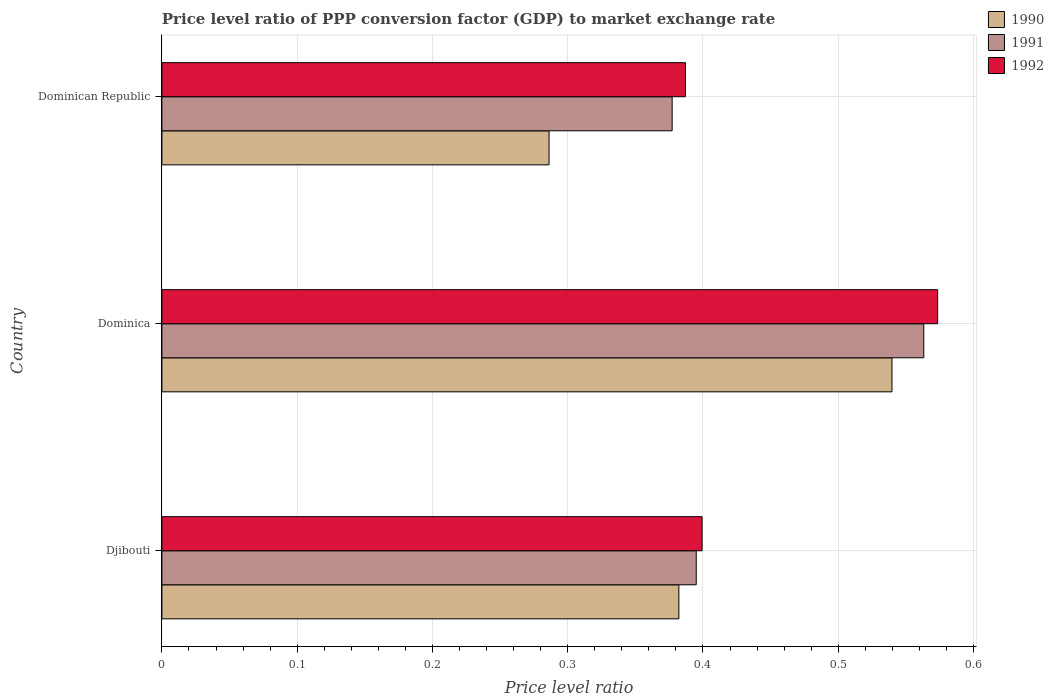How many different coloured bars are there?
Offer a terse response. 3. How many groups of bars are there?
Your answer should be compact. 3. Are the number of bars per tick equal to the number of legend labels?
Keep it short and to the point. Yes. How many bars are there on the 1st tick from the bottom?
Your response must be concise. 3. What is the label of the 3rd group of bars from the top?
Make the answer very short. Djibouti. What is the price level ratio in 1991 in Djibouti?
Offer a terse response. 0.4. Across all countries, what is the maximum price level ratio in 1990?
Make the answer very short. 0.54. Across all countries, what is the minimum price level ratio in 1991?
Make the answer very short. 0.38. In which country was the price level ratio in 1991 maximum?
Your answer should be very brief. Dominica. In which country was the price level ratio in 1990 minimum?
Provide a succinct answer. Dominican Republic. What is the total price level ratio in 1991 in the graph?
Make the answer very short. 1.34. What is the difference between the price level ratio in 1990 in Djibouti and that in Dominica?
Offer a terse response. -0.16. What is the difference between the price level ratio in 1992 in Dominica and the price level ratio in 1991 in Dominican Republic?
Ensure brevity in your answer.  0.2. What is the average price level ratio in 1991 per country?
Make the answer very short. 0.45. What is the difference between the price level ratio in 1990 and price level ratio in 1992 in Dominica?
Make the answer very short. -0.03. What is the ratio of the price level ratio in 1990 in Dominica to that in Dominican Republic?
Give a very brief answer. 1.89. Is the price level ratio in 1990 in Djibouti less than that in Dominica?
Offer a terse response. Yes. Is the difference between the price level ratio in 1990 in Djibouti and Dominican Republic greater than the difference between the price level ratio in 1992 in Djibouti and Dominican Republic?
Your answer should be compact. Yes. What is the difference between the highest and the second highest price level ratio in 1992?
Your answer should be compact. 0.17. What is the difference between the highest and the lowest price level ratio in 1990?
Offer a very short reply. 0.25. Is the sum of the price level ratio in 1990 in Djibouti and Dominica greater than the maximum price level ratio in 1991 across all countries?
Make the answer very short. Yes. What does the 1st bar from the top in Dominican Republic represents?
Ensure brevity in your answer.  1992. What does the 1st bar from the bottom in Dominica represents?
Keep it short and to the point. 1990. Does the graph contain any zero values?
Provide a succinct answer. No. Does the graph contain grids?
Keep it short and to the point. Yes. How many legend labels are there?
Your answer should be very brief. 3. How are the legend labels stacked?
Make the answer very short. Vertical. What is the title of the graph?
Keep it short and to the point. Price level ratio of PPP conversion factor (GDP) to market exchange rate. Does "1965" appear as one of the legend labels in the graph?
Offer a very short reply. No. What is the label or title of the X-axis?
Your answer should be very brief. Price level ratio. What is the label or title of the Y-axis?
Your answer should be compact. Country. What is the Price level ratio in 1990 in Djibouti?
Make the answer very short. 0.38. What is the Price level ratio in 1991 in Djibouti?
Make the answer very short. 0.4. What is the Price level ratio in 1992 in Djibouti?
Keep it short and to the point. 0.4. What is the Price level ratio in 1990 in Dominica?
Give a very brief answer. 0.54. What is the Price level ratio in 1991 in Dominica?
Make the answer very short. 0.56. What is the Price level ratio in 1992 in Dominica?
Provide a succinct answer. 0.57. What is the Price level ratio in 1990 in Dominican Republic?
Your response must be concise. 0.29. What is the Price level ratio in 1991 in Dominican Republic?
Ensure brevity in your answer.  0.38. What is the Price level ratio in 1992 in Dominican Republic?
Ensure brevity in your answer.  0.39. Across all countries, what is the maximum Price level ratio of 1990?
Your answer should be very brief. 0.54. Across all countries, what is the maximum Price level ratio of 1991?
Make the answer very short. 0.56. Across all countries, what is the maximum Price level ratio of 1992?
Offer a terse response. 0.57. Across all countries, what is the minimum Price level ratio of 1990?
Your answer should be compact. 0.29. Across all countries, what is the minimum Price level ratio in 1991?
Make the answer very short. 0.38. Across all countries, what is the minimum Price level ratio of 1992?
Keep it short and to the point. 0.39. What is the total Price level ratio of 1990 in the graph?
Your answer should be very brief. 1.21. What is the total Price level ratio in 1991 in the graph?
Your response must be concise. 1.34. What is the total Price level ratio of 1992 in the graph?
Your answer should be very brief. 1.36. What is the difference between the Price level ratio of 1990 in Djibouti and that in Dominica?
Your answer should be compact. -0.16. What is the difference between the Price level ratio of 1991 in Djibouti and that in Dominica?
Make the answer very short. -0.17. What is the difference between the Price level ratio of 1992 in Djibouti and that in Dominica?
Make the answer very short. -0.17. What is the difference between the Price level ratio in 1990 in Djibouti and that in Dominican Republic?
Your response must be concise. 0.1. What is the difference between the Price level ratio in 1991 in Djibouti and that in Dominican Republic?
Offer a terse response. 0.02. What is the difference between the Price level ratio in 1992 in Djibouti and that in Dominican Republic?
Give a very brief answer. 0.01. What is the difference between the Price level ratio of 1990 in Dominica and that in Dominican Republic?
Your response must be concise. 0.25. What is the difference between the Price level ratio of 1991 in Dominica and that in Dominican Republic?
Your response must be concise. 0.19. What is the difference between the Price level ratio in 1992 in Dominica and that in Dominican Republic?
Ensure brevity in your answer.  0.19. What is the difference between the Price level ratio of 1990 in Djibouti and the Price level ratio of 1991 in Dominica?
Offer a very short reply. -0.18. What is the difference between the Price level ratio of 1990 in Djibouti and the Price level ratio of 1992 in Dominica?
Make the answer very short. -0.19. What is the difference between the Price level ratio of 1991 in Djibouti and the Price level ratio of 1992 in Dominica?
Your answer should be very brief. -0.18. What is the difference between the Price level ratio of 1990 in Djibouti and the Price level ratio of 1991 in Dominican Republic?
Ensure brevity in your answer.  0.01. What is the difference between the Price level ratio in 1990 in Djibouti and the Price level ratio in 1992 in Dominican Republic?
Offer a terse response. -0. What is the difference between the Price level ratio of 1991 in Djibouti and the Price level ratio of 1992 in Dominican Republic?
Offer a very short reply. 0.01. What is the difference between the Price level ratio of 1990 in Dominica and the Price level ratio of 1991 in Dominican Republic?
Your response must be concise. 0.16. What is the difference between the Price level ratio in 1990 in Dominica and the Price level ratio in 1992 in Dominican Republic?
Provide a succinct answer. 0.15. What is the difference between the Price level ratio in 1991 in Dominica and the Price level ratio in 1992 in Dominican Republic?
Provide a short and direct response. 0.18. What is the average Price level ratio of 1990 per country?
Your response must be concise. 0.4. What is the average Price level ratio of 1991 per country?
Make the answer very short. 0.45. What is the average Price level ratio in 1992 per country?
Your answer should be very brief. 0.45. What is the difference between the Price level ratio of 1990 and Price level ratio of 1991 in Djibouti?
Keep it short and to the point. -0.01. What is the difference between the Price level ratio in 1990 and Price level ratio in 1992 in Djibouti?
Your response must be concise. -0.02. What is the difference between the Price level ratio in 1991 and Price level ratio in 1992 in Djibouti?
Keep it short and to the point. -0. What is the difference between the Price level ratio in 1990 and Price level ratio in 1991 in Dominica?
Provide a short and direct response. -0.02. What is the difference between the Price level ratio of 1990 and Price level ratio of 1992 in Dominica?
Make the answer very short. -0.03. What is the difference between the Price level ratio in 1991 and Price level ratio in 1992 in Dominica?
Offer a very short reply. -0.01. What is the difference between the Price level ratio in 1990 and Price level ratio in 1991 in Dominican Republic?
Ensure brevity in your answer.  -0.09. What is the difference between the Price level ratio of 1990 and Price level ratio of 1992 in Dominican Republic?
Your answer should be very brief. -0.1. What is the difference between the Price level ratio of 1991 and Price level ratio of 1992 in Dominican Republic?
Give a very brief answer. -0.01. What is the ratio of the Price level ratio in 1990 in Djibouti to that in Dominica?
Keep it short and to the point. 0.71. What is the ratio of the Price level ratio of 1991 in Djibouti to that in Dominica?
Your response must be concise. 0.7. What is the ratio of the Price level ratio of 1992 in Djibouti to that in Dominica?
Give a very brief answer. 0.7. What is the ratio of the Price level ratio in 1990 in Djibouti to that in Dominican Republic?
Keep it short and to the point. 1.34. What is the ratio of the Price level ratio in 1991 in Djibouti to that in Dominican Republic?
Provide a short and direct response. 1.05. What is the ratio of the Price level ratio in 1992 in Djibouti to that in Dominican Republic?
Give a very brief answer. 1.03. What is the ratio of the Price level ratio in 1990 in Dominica to that in Dominican Republic?
Your response must be concise. 1.89. What is the ratio of the Price level ratio of 1991 in Dominica to that in Dominican Republic?
Make the answer very short. 1.49. What is the ratio of the Price level ratio of 1992 in Dominica to that in Dominican Republic?
Provide a short and direct response. 1.48. What is the difference between the highest and the second highest Price level ratio of 1990?
Your answer should be very brief. 0.16. What is the difference between the highest and the second highest Price level ratio in 1991?
Your response must be concise. 0.17. What is the difference between the highest and the second highest Price level ratio of 1992?
Give a very brief answer. 0.17. What is the difference between the highest and the lowest Price level ratio of 1990?
Keep it short and to the point. 0.25. What is the difference between the highest and the lowest Price level ratio of 1991?
Your response must be concise. 0.19. What is the difference between the highest and the lowest Price level ratio in 1992?
Provide a succinct answer. 0.19. 